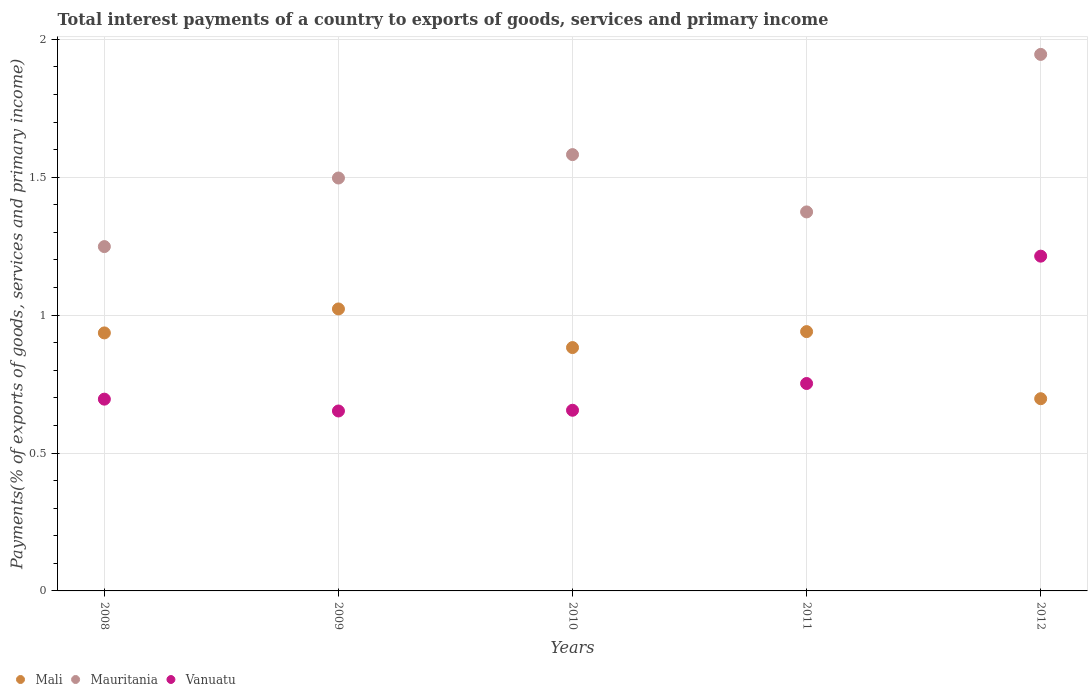How many different coloured dotlines are there?
Your answer should be compact. 3. Is the number of dotlines equal to the number of legend labels?
Your answer should be very brief. Yes. What is the total interest payments in Mauritania in 2009?
Give a very brief answer. 1.5. Across all years, what is the maximum total interest payments in Mali?
Offer a terse response. 1.02. Across all years, what is the minimum total interest payments in Mali?
Offer a terse response. 0.7. What is the total total interest payments in Mauritania in the graph?
Provide a succinct answer. 7.65. What is the difference between the total interest payments in Mali in 2008 and that in 2011?
Your answer should be very brief. -0. What is the difference between the total interest payments in Mali in 2011 and the total interest payments in Mauritania in 2008?
Provide a short and direct response. -0.31. What is the average total interest payments in Mali per year?
Your answer should be very brief. 0.9. In the year 2008, what is the difference between the total interest payments in Vanuatu and total interest payments in Mauritania?
Offer a terse response. -0.55. In how many years, is the total interest payments in Vanuatu greater than 1.3 %?
Provide a short and direct response. 0. What is the ratio of the total interest payments in Vanuatu in 2009 to that in 2012?
Provide a short and direct response. 0.54. What is the difference between the highest and the second highest total interest payments in Mauritania?
Offer a terse response. 0.36. What is the difference between the highest and the lowest total interest payments in Vanuatu?
Give a very brief answer. 0.56. Is the sum of the total interest payments in Vanuatu in 2010 and 2012 greater than the maximum total interest payments in Mali across all years?
Make the answer very short. Yes. Is it the case that in every year, the sum of the total interest payments in Vanuatu and total interest payments in Mauritania  is greater than the total interest payments in Mali?
Your answer should be compact. Yes. Is the total interest payments in Mauritania strictly greater than the total interest payments in Mali over the years?
Keep it short and to the point. Yes. Is the total interest payments in Vanuatu strictly less than the total interest payments in Mali over the years?
Your response must be concise. No. How many dotlines are there?
Your answer should be very brief. 3. Does the graph contain grids?
Offer a terse response. Yes. Where does the legend appear in the graph?
Ensure brevity in your answer.  Bottom left. How are the legend labels stacked?
Offer a terse response. Horizontal. What is the title of the graph?
Your answer should be very brief. Total interest payments of a country to exports of goods, services and primary income. What is the label or title of the X-axis?
Offer a very short reply. Years. What is the label or title of the Y-axis?
Ensure brevity in your answer.  Payments(% of exports of goods, services and primary income). What is the Payments(% of exports of goods, services and primary income) of Mali in 2008?
Your answer should be compact. 0.94. What is the Payments(% of exports of goods, services and primary income) in Mauritania in 2008?
Ensure brevity in your answer.  1.25. What is the Payments(% of exports of goods, services and primary income) of Vanuatu in 2008?
Give a very brief answer. 0.7. What is the Payments(% of exports of goods, services and primary income) in Mali in 2009?
Provide a short and direct response. 1.02. What is the Payments(% of exports of goods, services and primary income) of Mauritania in 2009?
Your answer should be compact. 1.5. What is the Payments(% of exports of goods, services and primary income) in Vanuatu in 2009?
Your answer should be very brief. 0.65. What is the Payments(% of exports of goods, services and primary income) in Mali in 2010?
Provide a short and direct response. 0.88. What is the Payments(% of exports of goods, services and primary income) of Mauritania in 2010?
Provide a short and direct response. 1.58. What is the Payments(% of exports of goods, services and primary income) of Vanuatu in 2010?
Keep it short and to the point. 0.66. What is the Payments(% of exports of goods, services and primary income) of Mali in 2011?
Your response must be concise. 0.94. What is the Payments(% of exports of goods, services and primary income) in Mauritania in 2011?
Make the answer very short. 1.37. What is the Payments(% of exports of goods, services and primary income) in Vanuatu in 2011?
Keep it short and to the point. 0.75. What is the Payments(% of exports of goods, services and primary income) in Mali in 2012?
Give a very brief answer. 0.7. What is the Payments(% of exports of goods, services and primary income) of Mauritania in 2012?
Provide a succinct answer. 1.95. What is the Payments(% of exports of goods, services and primary income) in Vanuatu in 2012?
Offer a very short reply. 1.21. Across all years, what is the maximum Payments(% of exports of goods, services and primary income) in Mali?
Provide a short and direct response. 1.02. Across all years, what is the maximum Payments(% of exports of goods, services and primary income) of Mauritania?
Provide a short and direct response. 1.95. Across all years, what is the maximum Payments(% of exports of goods, services and primary income) in Vanuatu?
Keep it short and to the point. 1.21. Across all years, what is the minimum Payments(% of exports of goods, services and primary income) in Mali?
Your answer should be very brief. 0.7. Across all years, what is the minimum Payments(% of exports of goods, services and primary income) in Mauritania?
Ensure brevity in your answer.  1.25. Across all years, what is the minimum Payments(% of exports of goods, services and primary income) in Vanuatu?
Make the answer very short. 0.65. What is the total Payments(% of exports of goods, services and primary income) of Mali in the graph?
Your response must be concise. 4.48. What is the total Payments(% of exports of goods, services and primary income) of Mauritania in the graph?
Offer a very short reply. 7.65. What is the total Payments(% of exports of goods, services and primary income) in Vanuatu in the graph?
Offer a terse response. 3.97. What is the difference between the Payments(% of exports of goods, services and primary income) in Mali in 2008 and that in 2009?
Ensure brevity in your answer.  -0.09. What is the difference between the Payments(% of exports of goods, services and primary income) in Mauritania in 2008 and that in 2009?
Ensure brevity in your answer.  -0.25. What is the difference between the Payments(% of exports of goods, services and primary income) of Vanuatu in 2008 and that in 2009?
Your response must be concise. 0.04. What is the difference between the Payments(% of exports of goods, services and primary income) of Mali in 2008 and that in 2010?
Offer a very short reply. 0.05. What is the difference between the Payments(% of exports of goods, services and primary income) of Mauritania in 2008 and that in 2010?
Offer a very short reply. -0.33. What is the difference between the Payments(% of exports of goods, services and primary income) of Vanuatu in 2008 and that in 2010?
Your answer should be compact. 0.04. What is the difference between the Payments(% of exports of goods, services and primary income) of Mali in 2008 and that in 2011?
Make the answer very short. -0. What is the difference between the Payments(% of exports of goods, services and primary income) of Mauritania in 2008 and that in 2011?
Your answer should be very brief. -0.13. What is the difference between the Payments(% of exports of goods, services and primary income) in Vanuatu in 2008 and that in 2011?
Ensure brevity in your answer.  -0.06. What is the difference between the Payments(% of exports of goods, services and primary income) of Mali in 2008 and that in 2012?
Your answer should be very brief. 0.24. What is the difference between the Payments(% of exports of goods, services and primary income) in Mauritania in 2008 and that in 2012?
Ensure brevity in your answer.  -0.7. What is the difference between the Payments(% of exports of goods, services and primary income) of Vanuatu in 2008 and that in 2012?
Make the answer very short. -0.52. What is the difference between the Payments(% of exports of goods, services and primary income) in Mali in 2009 and that in 2010?
Offer a terse response. 0.14. What is the difference between the Payments(% of exports of goods, services and primary income) in Mauritania in 2009 and that in 2010?
Your response must be concise. -0.08. What is the difference between the Payments(% of exports of goods, services and primary income) of Vanuatu in 2009 and that in 2010?
Make the answer very short. -0. What is the difference between the Payments(% of exports of goods, services and primary income) in Mali in 2009 and that in 2011?
Offer a very short reply. 0.08. What is the difference between the Payments(% of exports of goods, services and primary income) in Mauritania in 2009 and that in 2011?
Provide a succinct answer. 0.12. What is the difference between the Payments(% of exports of goods, services and primary income) of Vanuatu in 2009 and that in 2011?
Ensure brevity in your answer.  -0.1. What is the difference between the Payments(% of exports of goods, services and primary income) in Mali in 2009 and that in 2012?
Offer a very short reply. 0.33. What is the difference between the Payments(% of exports of goods, services and primary income) of Mauritania in 2009 and that in 2012?
Your answer should be very brief. -0.45. What is the difference between the Payments(% of exports of goods, services and primary income) of Vanuatu in 2009 and that in 2012?
Provide a succinct answer. -0.56. What is the difference between the Payments(% of exports of goods, services and primary income) of Mali in 2010 and that in 2011?
Your response must be concise. -0.06. What is the difference between the Payments(% of exports of goods, services and primary income) in Mauritania in 2010 and that in 2011?
Make the answer very short. 0.21. What is the difference between the Payments(% of exports of goods, services and primary income) in Vanuatu in 2010 and that in 2011?
Keep it short and to the point. -0.1. What is the difference between the Payments(% of exports of goods, services and primary income) in Mali in 2010 and that in 2012?
Provide a short and direct response. 0.19. What is the difference between the Payments(% of exports of goods, services and primary income) of Mauritania in 2010 and that in 2012?
Provide a succinct answer. -0.36. What is the difference between the Payments(% of exports of goods, services and primary income) in Vanuatu in 2010 and that in 2012?
Keep it short and to the point. -0.56. What is the difference between the Payments(% of exports of goods, services and primary income) in Mali in 2011 and that in 2012?
Provide a short and direct response. 0.24. What is the difference between the Payments(% of exports of goods, services and primary income) in Mauritania in 2011 and that in 2012?
Offer a very short reply. -0.57. What is the difference between the Payments(% of exports of goods, services and primary income) in Vanuatu in 2011 and that in 2012?
Keep it short and to the point. -0.46. What is the difference between the Payments(% of exports of goods, services and primary income) of Mali in 2008 and the Payments(% of exports of goods, services and primary income) of Mauritania in 2009?
Ensure brevity in your answer.  -0.56. What is the difference between the Payments(% of exports of goods, services and primary income) of Mali in 2008 and the Payments(% of exports of goods, services and primary income) of Vanuatu in 2009?
Offer a terse response. 0.28. What is the difference between the Payments(% of exports of goods, services and primary income) in Mauritania in 2008 and the Payments(% of exports of goods, services and primary income) in Vanuatu in 2009?
Offer a very short reply. 0.6. What is the difference between the Payments(% of exports of goods, services and primary income) in Mali in 2008 and the Payments(% of exports of goods, services and primary income) in Mauritania in 2010?
Make the answer very short. -0.65. What is the difference between the Payments(% of exports of goods, services and primary income) in Mali in 2008 and the Payments(% of exports of goods, services and primary income) in Vanuatu in 2010?
Provide a succinct answer. 0.28. What is the difference between the Payments(% of exports of goods, services and primary income) of Mauritania in 2008 and the Payments(% of exports of goods, services and primary income) of Vanuatu in 2010?
Your response must be concise. 0.59. What is the difference between the Payments(% of exports of goods, services and primary income) of Mali in 2008 and the Payments(% of exports of goods, services and primary income) of Mauritania in 2011?
Your response must be concise. -0.44. What is the difference between the Payments(% of exports of goods, services and primary income) in Mali in 2008 and the Payments(% of exports of goods, services and primary income) in Vanuatu in 2011?
Ensure brevity in your answer.  0.18. What is the difference between the Payments(% of exports of goods, services and primary income) in Mauritania in 2008 and the Payments(% of exports of goods, services and primary income) in Vanuatu in 2011?
Make the answer very short. 0.5. What is the difference between the Payments(% of exports of goods, services and primary income) of Mali in 2008 and the Payments(% of exports of goods, services and primary income) of Mauritania in 2012?
Give a very brief answer. -1.01. What is the difference between the Payments(% of exports of goods, services and primary income) of Mali in 2008 and the Payments(% of exports of goods, services and primary income) of Vanuatu in 2012?
Keep it short and to the point. -0.28. What is the difference between the Payments(% of exports of goods, services and primary income) of Mauritania in 2008 and the Payments(% of exports of goods, services and primary income) of Vanuatu in 2012?
Make the answer very short. 0.03. What is the difference between the Payments(% of exports of goods, services and primary income) in Mali in 2009 and the Payments(% of exports of goods, services and primary income) in Mauritania in 2010?
Provide a succinct answer. -0.56. What is the difference between the Payments(% of exports of goods, services and primary income) of Mali in 2009 and the Payments(% of exports of goods, services and primary income) of Vanuatu in 2010?
Ensure brevity in your answer.  0.37. What is the difference between the Payments(% of exports of goods, services and primary income) in Mauritania in 2009 and the Payments(% of exports of goods, services and primary income) in Vanuatu in 2010?
Your answer should be compact. 0.84. What is the difference between the Payments(% of exports of goods, services and primary income) in Mali in 2009 and the Payments(% of exports of goods, services and primary income) in Mauritania in 2011?
Your answer should be compact. -0.35. What is the difference between the Payments(% of exports of goods, services and primary income) of Mali in 2009 and the Payments(% of exports of goods, services and primary income) of Vanuatu in 2011?
Give a very brief answer. 0.27. What is the difference between the Payments(% of exports of goods, services and primary income) in Mauritania in 2009 and the Payments(% of exports of goods, services and primary income) in Vanuatu in 2011?
Make the answer very short. 0.74. What is the difference between the Payments(% of exports of goods, services and primary income) in Mali in 2009 and the Payments(% of exports of goods, services and primary income) in Mauritania in 2012?
Give a very brief answer. -0.92. What is the difference between the Payments(% of exports of goods, services and primary income) of Mali in 2009 and the Payments(% of exports of goods, services and primary income) of Vanuatu in 2012?
Give a very brief answer. -0.19. What is the difference between the Payments(% of exports of goods, services and primary income) in Mauritania in 2009 and the Payments(% of exports of goods, services and primary income) in Vanuatu in 2012?
Offer a terse response. 0.28. What is the difference between the Payments(% of exports of goods, services and primary income) of Mali in 2010 and the Payments(% of exports of goods, services and primary income) of Mauritania in 2011?
Your response must be concise. -0.49. What is the difference between the Payments(% of exports of goods, services and primary income) of Mali in 2010 and the Payments(% of exports of goods, services and primary income) of Vanuatu in 2011?
Keep it short and to the point. 0.13. What is the difference between the Payments(% of exports of goods, services and primary income) of Mauritania in 2010 and the Payments(% of exports of goods, services and primary income) of Vanuatu in 2011?
Offer a very short reply. 0.83. What is the difference between the Payments(% of exports of goods, services and primary income) of Mali in 2010 and the Payments(% of exports of goods, services and primary income) of Mauritania in 2012?
Make the answer very short. -1.06. What is the difference between the Payments(% of exports of goods, services and primary income) in Mali in 2010 and the Payments(% of exports of goods, services and primary income) in Vanuatu in 2012?
Offer a terse response. -0.33. What is the difference between the Payments(% of exports of goods, services and primary income) in Mauritania in 2010 and the Payments(% of exports of goods, services and primary income) in Vanuatu in 2012?
Offer a very short reply. 0.37. What is the difference between the Payments(% of exports of goods, services and primary income) of Mali in 2011 and the Payments(% of exports of goods, services and primary income) of Mauritania in 2012?
Offer a terse response. -1.01. What is the difference between the Payments(% of exports of goods, services and primary income) in Mali in 2011 and the Payments(% of exports of goods, services and primary income) in Vanuatu in 2012?
Make the answer very short. -0.27. What is the difference between the Payments(% of exports of goods, services and primary income) of Mauritania in 2011 and the Payments(% of exports of goods, services and primary income) of Vanuatu in 2012?
Your answer should be compact. 0.16. What is the average Payments(% of exports of goods, services and primary income) of Mali per year?
Ensure brevity in your answer.  0.9. What is the average Payments(% of exports of goods, services and primary income) in Mauritania per year?
Your answer should be very brief. 1.53. What is the average Payments(% of exports of goods, services and primary income) of Vanuatu per year?
Provide a short and direct response. 0.79. In the year 2008, what is the difference between the Payments(% of exports of goods, services and primary income) of Mali and Payments(% of exports of goods, services and primary income) of Mauritania?
Make the answer very short. -0.31. In the year 2008, what is the difference between the Payments(% of exports of goods, services and primary income) in Mali and Payments(% of exports of goods, services and primary income) in Vanuatu?
Keep it short and to the point. 0.24. In the year 2008, what is the difference between the Payments(% of exports of goods, services and primary income) in Mauritania and Payments(% of exports of goods, services and primary income) in Vanuatu?
Make the answer very short. 0.55. In the year 2009, what is the difference between the Payments(% of exports of goods, services and primary income) of Mali and Payments(% of exports of goods, services and primary income) of Mauritania?
Your answer should be compact. -0.47. In the year 2009, what is the difference between the Payments(% of exports of goods, services and primary income) in Mali and Payments(% of exports of goods, services and primary income) in Vanuatu?
Your answer should be very brief. 0.37. In the year 2009, what is the difference between the Payments(% of exports of goods, services and primary income) of Mauritania and Payments(% of exports of goods, services and primary income) of Vanuatu?
Ensure brevity in your answer.  0.84. In the year 2010, what is the difference between the Payments(% of exports of goods, services and primary income) in Mali and Payments(% of exports of goods, services and primary income) in Mauritania?
Provide a short and direct response. -0.7. In the year 2010, what is the difference between the Payments(% of exports of goods, services and primary income) in Mali and Payments(% of exports of goods, services and primary income) in Vanuatu?
Your response must be concise. 0.23. In the year 2010, what is the difference between the Payments(% of exports of goods, services and primary income) in Mauritania and Payments(% of exports of goods, services and primary income) in Vanuatu?
Your answer should be very brief. 0.93. In the year 2011, what is the difference between the Payments(% of exports of goods, services and primary income) in Mali and Payments(% of exports of goods, services and primary income) in Mauritania?
Provide a short and direct response. -0.43. In the year 2011, what is the difference between the Payments(% of exports of goods, services and primary income) of Mali and Payments(% of exports of goods, services and primary income) of Vanuatu?
Provide a short and direct response. 0.19. In the year 2011, what is the difference between the Payments(% of exports of goods, services and primary income) of Mauritania and Payments(% of exports of goods, services and primary income) of Vanuatu?
Offer a terse response. 0.62. In the year 2012, what is the difference between the Payments(% of exports of goods, services and primary income) in Mali and Payments(% of exports of goods, services and primary income) in Mauritania?
Offer a very short reply. -1.25. In the year 2012, what is the difference between the Payments(% of exports of goods, services and primary income) in Mali and Payments(% of exports of goods, services and primary income) in Vanuatu?
Offer a terse response. -0.52. In the year 2012, what is the difference between the Payments(% of exports of goods, services and primary income) of Mauritania and Payments(% of exports of goods, services and primary income) of Vanuatu?
Your answer should be very brief. 0.73. What is the ratio of the Payments(% of exports of goods, services and primary income) of Mali in 2008 to that in 2009?
Offer a terse response. 0.92. What is the ratio of the Payments(% of exports of goods, services and primary income) of Mauritania in 2008 to that in 2009?
Keep it short and to the point. 0.83. What is the ratio of the Payments(% of exports of goods, services and primary income) in Vanuatu in 2008 to that in 2009?
Keep it short and to the point. 1.07. What is the ratio of the Payments(% of exports of goods, services and primary income) in Mali in 2008 to that in 2010?
Your answer should be very brief. 1.06. What is the ratio of the Payments(% of exports of goods, services and primary income) in Mauritania in 2008 to that in 2010?
Your response must be concise. 0.79. What is the ratio of the Payments(% of exports of goods, services and primary income) of Vanuatu in 2008 to that in 2010?
Provide a succinct answer. 1.06. What is the ratio of the Payments(% of exports of goods, services and primary income) in Mali in 2008 to that in 2011?
Your response must be concise. 0.99. What is the ratio of the Payments(% of exports of goods, services and primary income) in Mauritania in 2008 to that in 2011?
Make the answer very short. 0.91. What is the ratio of the Payments(% of exports of goods, services and primary income) in Vanuatu in 2008 to that in 2011?
Keep it short and to the point. 0.92. What is the ratio of the Payments(% of exports of goods, services and primary income) of Mali in 2008 to that in 2012?
Offer a terse response. 1.34. What is the ratio of the Payments(% of exports of goods, services and primary income) of Mauritania in 2008 to that in 2012?
Give a very brief answer. 0.64. What is the ratio of the Payments(% of exports of goods, services and primary income) in Vanuatu in 2008 to that in 2012?
Keep it short and to the point. 0.57. What is the ratio of the Payments(% of exports of goods, services and primary income) in Mali in 2009 to that in 2010?
Ensure brevity in your answer.  1.16. What is the ratio of the Payments(% of exports of goods, services and primary income) in Mauritania in 2009 to that in 2010?
Your answer should be compact. 0.95. What is the ratio of the Payments(% of exports of goods, services and primary income) of Mali in 2009 to that in 2011?
Your answer should be very brief. 1.09. What is the ratio of the Payments(% of exports of goods, services and primary income) of Mauritania in 2009 to that in 2011?
Provide a short and direct response. 1.09. What is the ratio of the Payments(% of exports of goods, services and primary income) in Vanuatu in 2009 to that in 2011?
Keep it short and to the point. 0.87. What is the ratio of the Payments(% of exports of goods, services and primary income) of Mali in 2009 to that in 2012?
Keep it short and to the point. 1.47. What is the ratio of the Payments(% of exports of goods, services and primary income) of Mauritania in 2009 to that in 2012?
Offer a very short reply. 0.77. What is the ratio of the Payments(% of exports of goods, services and primary income) in Vanuatu in 2009 to that in 2012?
Offer a terse response. 0.54. What is the ratio of the Payments(% of exports of goods, services and primary income) in Mali in 2010 to that in 2011?
Ensure brevity in your answer.  0.94. What is the ratio of the Payments(% of exports of goods, services and primary income) of Mauritania in 2010 to that in 2011?
Your response must be concise. 1.15. What is the ratio of the Payments(% of exports of goods, services and primary income) in Vanuatu in 2010 to that in 2011?
Your response must be concise. 0.87. What is the ratio of the Payments(% of exports of goods, services and primary income) of Mali in 2010 to that in 2012?
Your answer should be compact. 1.27. What is the ratio of the Payments(% of exports of goods, services and primary income) in Mauritania in 2010 to that in 2012?
Your response must be concise. 0.81. What is the ratio of the Payments(% of exports of goods, services and primary income) in Vanuatu in 2010 to that in 2012?
Ensure brevity in your answer.  0.54. What is the ratio of the Payments(% of exports of goods, services and primary income) of Mali in 2011 to that in 2012?
Your answer should be compact. 1.35. What is the ratio of the Payments(% of exports of goods, services and primary income) of Mauritania in 2011 to that in 2012?
Your answer should be very brief. 0.71. What is the ratio of the Payments(% of exports of goods, services and primary income) in Vanuatu in 2011 to that in 2012?
Give a very brief answer. 0.62. What is the difference between the highest and the second highest Payments(% of exports of goods, services and primary income) in Mali?
Provide a short and direct response. 0.08. What is the difference between the highest and the second highest Payments(% of exports of goods, services and primary income) of Mauritania?
Offer a very short reply. 0.36. What is the difference between the highest and the second highest Payments(% of exports of goods, services and primary income) of Vanuatu?
Offer a terse response. 0.46. What is the difference between the highest and the lowest Payments(% of exports of goods, services and primary income) of Mali?
Keep it short and to the point. 0.33. What is the difference between the highest and the lowest Payments(% of exports of goods, services and primary income) in Mauritania?
Your response must be concise. 0.7. What is the difference between the highest and the lowest Payments(% of exports of goods, services and primary income) in Vanuatu?
Give a very brief answer. 0.56. 